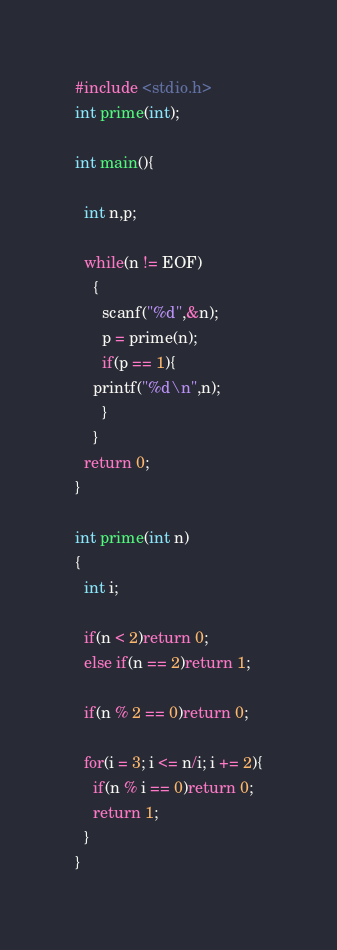Convert code to text. <code><loc_0><loc_0><loc_500><loc_500><_C_>#include <stdio.h>
int prime(int);

int main(){

  int n,p;

  while(n != EOF)
    {
      scanf("%d",&n);
      p = prime(n);
      if(p == 1){
	printf("%d\n",n);
      }
    }
  return 0;
}

int prime(int n)
{
  int i;

  if(n < 2)return 0;
  else if(n == 2)return 1;

  if(n % 2 == 0)return 0;

  for(i = 3; i <= n/i; i += 2){
    if(n % i == 0)return 0;
    return 1;
  }
}</code> 